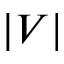<formula> <loc_0><loc_0><loc_500><loc_500>| V |</formula> 